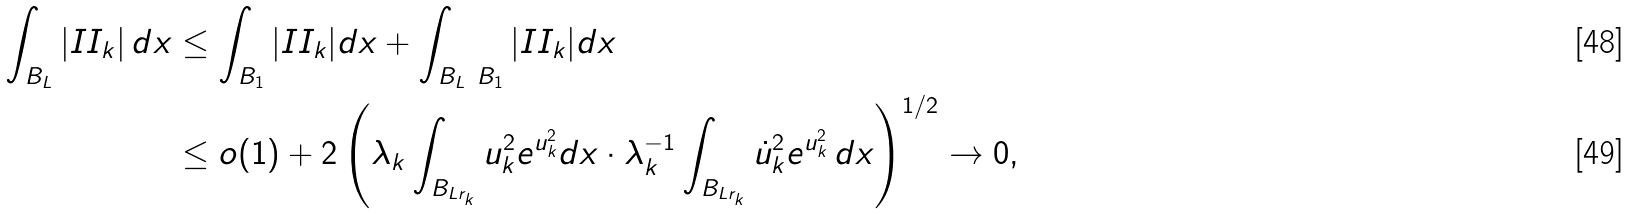Convert formula to latex. <formula><loc_0><loc_0><loc_500><loc_500>\int _ { B _ { L } } | I I _ { k } | \, d x & \leq \int _ { B _ { 1 } } | I I _ { k } | d x + \int _ { B _ { L } \ B _ { 1 } } | I I _ { k } | d x \\ & \leq o ( 1 ) + 2 \left ( \lambda _ { k } \int _ { B _ { L r _ { k } } } u _ { k } ^ { 2 } e ^ { u _ { k } ^ { 2 } } d x \cdot \lambda _ { k } ^ { - 1 } \int _ { B _ { L r _ { k } } } \dot { u } _ { k } ^ { 2 } e ^ { u _ { k } ^ { 2 } } \, d x \right ) ^ { 1 / 2 } \rightarrow 0 ,</formula> 